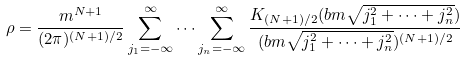<formula> <loc_0><loc_0><loc_500><loc_500>\rho = \frac { m ^ { N + 1 } } { ( 2 \pi ) ^ { ( N + 1 ) / 2 } } \sum _ { j _ { 1 } = - \infty } ^ { \infty } \dots \sum _ { j _ { n } = - \infty } ^ { \infty } \frac { K _ { ( N + 1 ) / 2 } ( b m \sqrt { j _ { 1 } ^ { 2 } + \dots + j _ { n } ^ { 2 } } ) } { ( b m \sqrt { j _ { 1 } ^ { 2 } + \dots + j _ { n } ^ { 2 } } ) ^ { ( N + 1 ) / 2 } }</formula> 